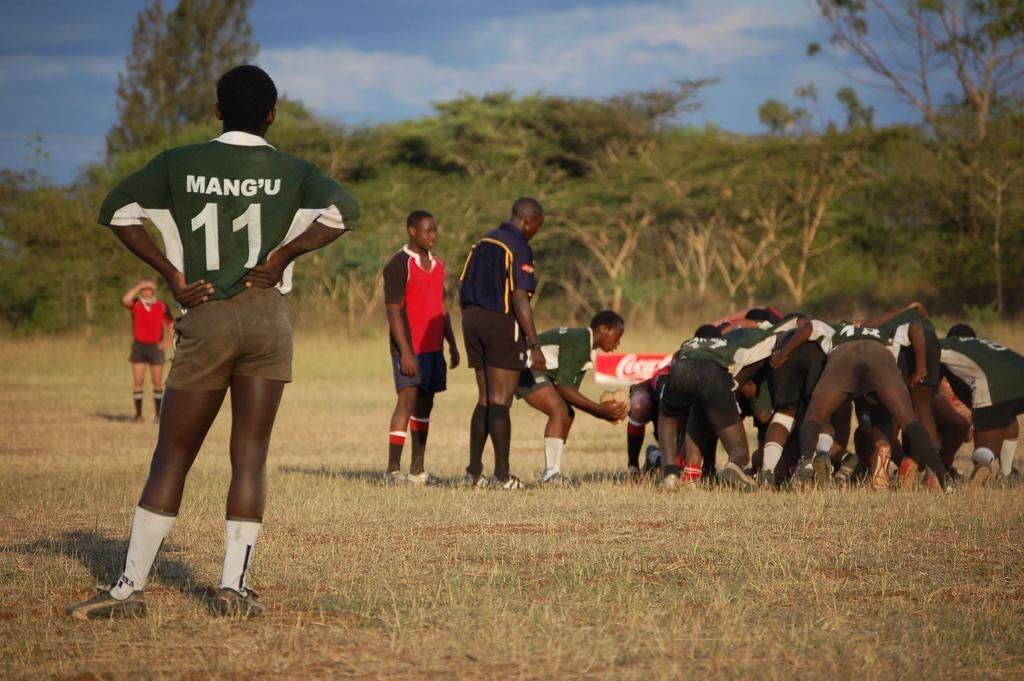Provide a one-sentence caption for the provided image. Man wearing a green number 11 jersey watching others. 